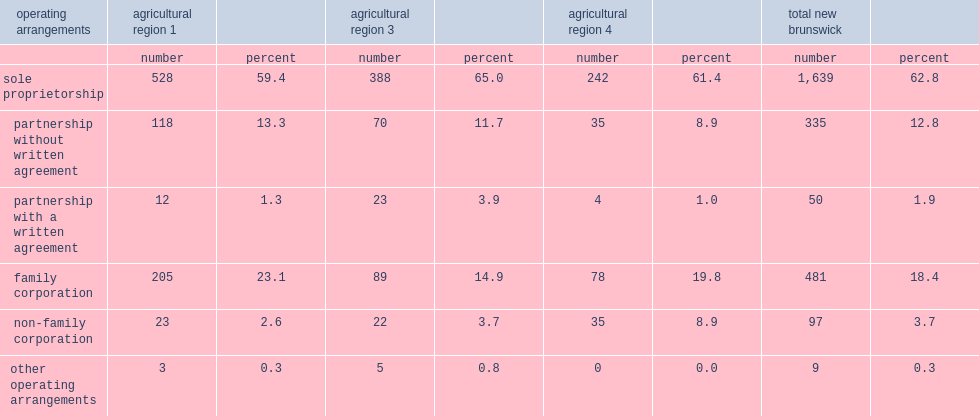What kind of operating arrangement is the majority of farms in new brunswick's three agricultural regions? Sole proprietorship. 